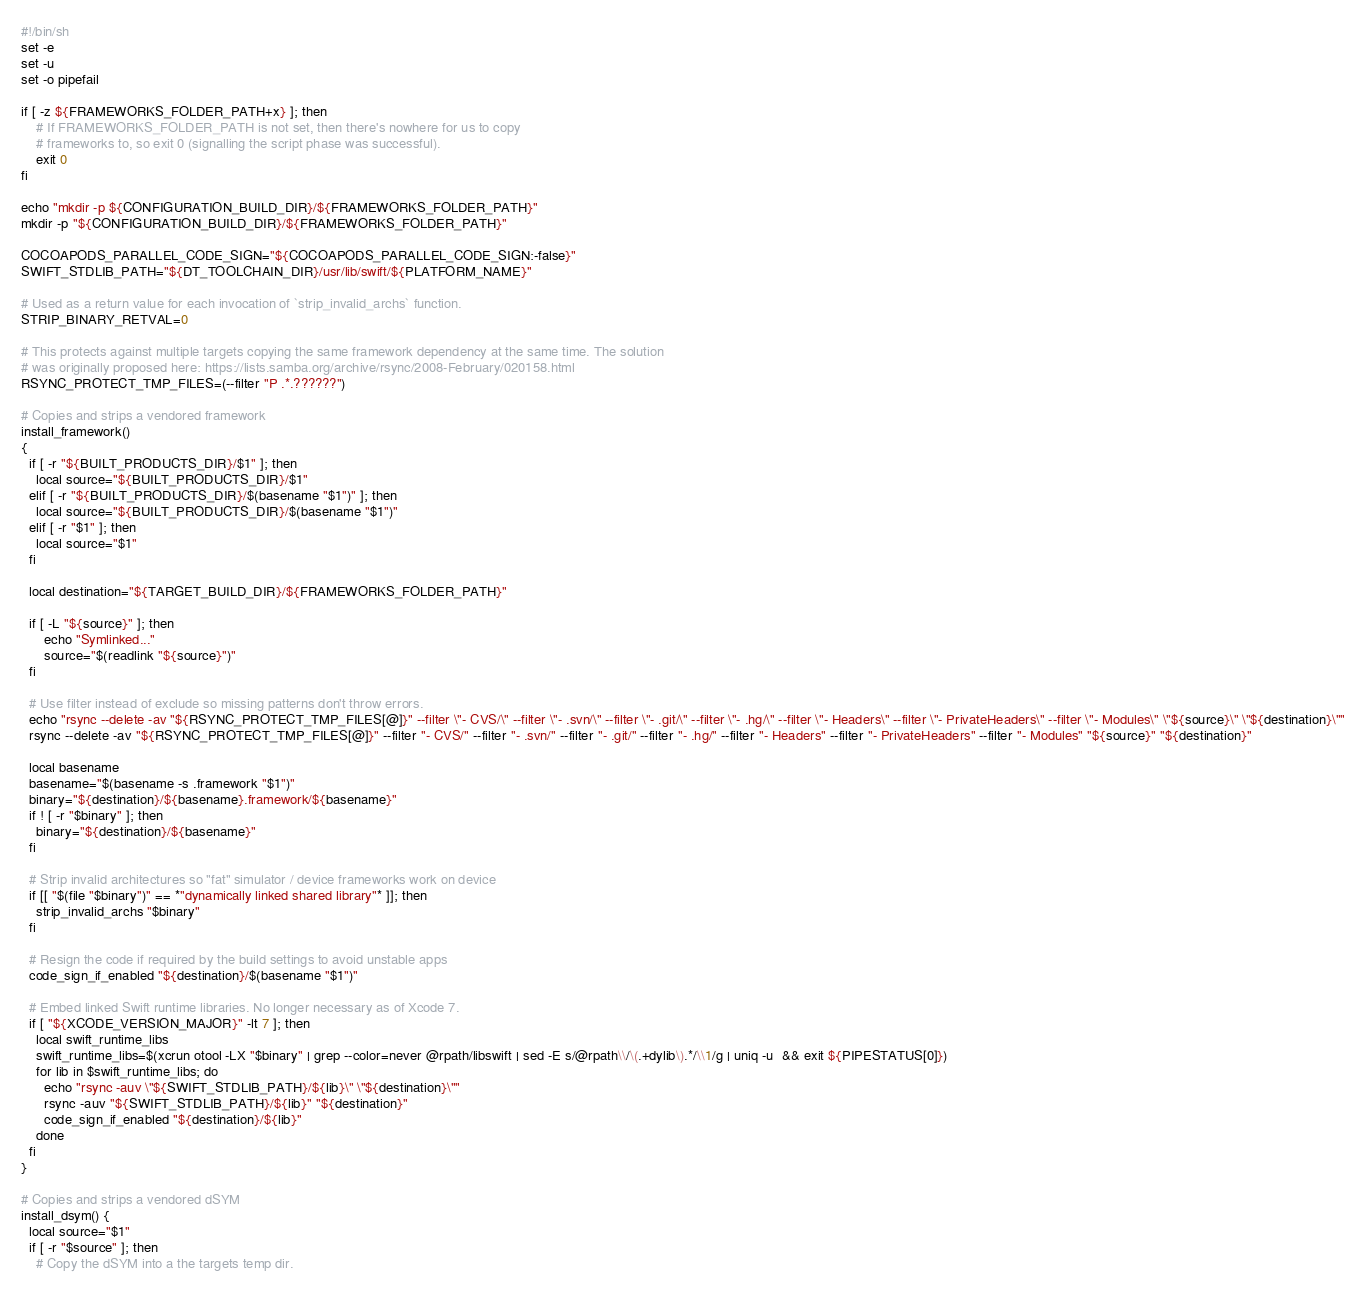Convert code to text. <code><loc_0><loc_0><loc_500><loc_500><_Bash_>#!/bin/sh
set -e
set -u
set -o pipefail

if [ -z ${FRAMEWORKS_FOLDER_PATH+x} ]; then
    # If FRAMEWORKS_FOLDER_PATH is not set, then there's nowhere for us to copy
    # frameworks to, so exit 0 (signalling the script phase was successful).
    exit 0
fi

echo "mkdir -p ${CONFIGURATION_BUILD_DIR}/${FRAMEWORKS_FOLDER_PATH}"
mkdir -p "${CONFIGURATION_BUILD_DIR}/${FRAMEWORKS_FOLDER_PATH}"

COCOAPODS_PARALLEL_CODE_SIGN="${COCOAPODS_PARALLEL_CODE_SIGN:-false}"
SWIFT_STDLIB_PATH="${DT_TOOLCHAIN_DIR}/usr/lib/swift/${PLATFORM_NAME}"

# Used as a return value for each invocation of `strip_invalid_archs` function.
STRIP_BINARY_RETVAL=0

# This protects against multiple targets copying the same framework dependency at the same time. The solution
# was originally proposed here: https://lists.samba.org/archive/rsync/2008-February/020158.html
RSYNC_PROTECT_TMP_FILES=(--filter "P .*.??????")

# Copies and strips a vendored framework
install_framework()
{
  if [ -r "${BUILT_PRODUCTS_DIR}/$1" ]; then
    local source="${BUILT_PRODUCTS_DIR}/$1"
  elif [ -r "${BUILT_PRODUCTS_DIR}/$(basename "$1")" ]; then
    local source="${BUILT_PRODUCTS_DIR}/$(basename "$1")"
  elif [ -r "$1" ]; then
    local source="$1"
  fi

  local destination="${TARGET_BUILD_DIR}/${FRAMEWORKS_FOLDER_PATH}"

  if [ -L "${source}" ]; then
      echo "Symlinked..."
      source="$(readlink "${source}")"
  fi

  # Use filter instead of exclude so missing patterns don't throw errors.
  echo "rsync --delete -av "${RSYNC_PROTECT_TMP_FILES[@]}" --filter \"- CVS/\" --filter \"- .svn/\" --filter \"- .git/\" --filter \"- .hg/\" --filter \"- Headers\" --filter \"- PrivateHeaders\" --filter \"- Modules\" \"${source}\" \"${destination}\""
  rsync --delete -av "${RSYNC_PROTECT_TMP_FILES[@]}" --filter "- CVS/" --filter "- .svn/" --filter "- .git/" --filter "- .hg/" --filter "- Headers" --filter "- PrivateHeaders" --filter "- Modules" "${source}" "${destination}"

  local basename
  basename="$(basename -s .framework "$1")"
  binary="${destination}/${basename}.framework/${basename}"
  if ! [ -r "$binary" ]; then
    binary="${destination}/${basename}"
  fi

  # Strip invalid architectures so "fat" simulator / device frameworks work on device
  if [[ "$(file "$binary")" == *"dynamically linked shared library"* ]]; then
    strip_invalid_archs "$binary"
  fi

  # Resign the code if required by the build settings to avoid unstable apps
  code_sign_if_enabled "${destination}/$(basename "$1")"

  # Embed linked Swift runtime libraries. No longer necessary as of Xcode 7.
  if [ "${XCODE_VERSION_MAJOR}" -lt 7 ]; then
    local swift_runtime_libs
    swift_runtime_libs=$(xcrun otool -LX "$binary" | grep --color=never @rpath/libswift | sed -E s/@rpath\\/\(.+dylib\).*/\\1/g | uniq -u  && exit ${PIPESTATUS[0]})
    for lib in $swift_runtime_libs; do
      echo "rsync -auv \"${SWIFT_STDLIB_PATH}/${lib}\" \"${destination}\""
      rsync -auv "${SWIFT_STDLIB_PATH}/${lib}" "${destination}"
      code_sign_if_enabled "${destination}/${lib}"
    done
  fi
}

# Copies and strips a vendored dSYM
install_dsym() {
  local source="$1"
  if [ -r "$source" ]; then
    # Copy the dSYM into a the targets temp dir.</code> 